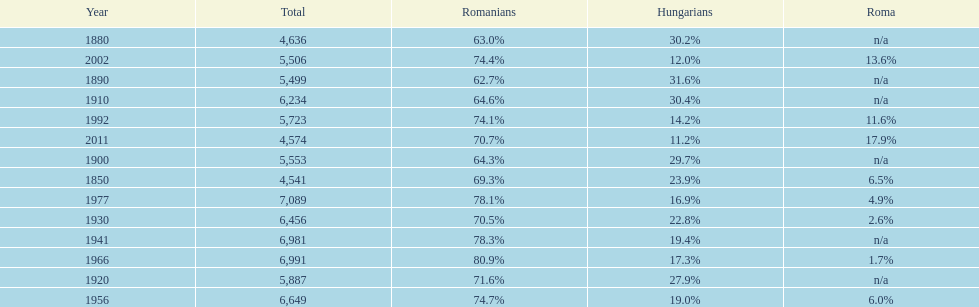What percent of the population were romanians according to the last year on this chart? 70.7%. 